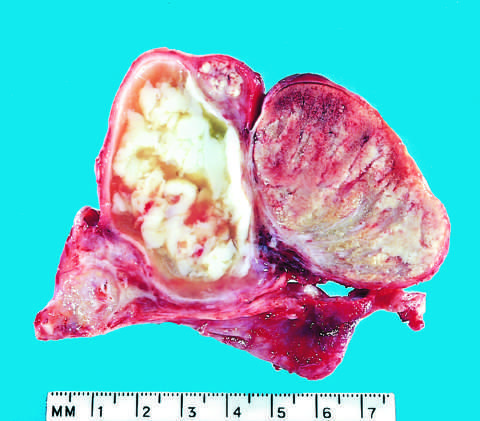what is acute epididymitis caused by?
Answer the question using a single word or phrase. Gonococcal infection 